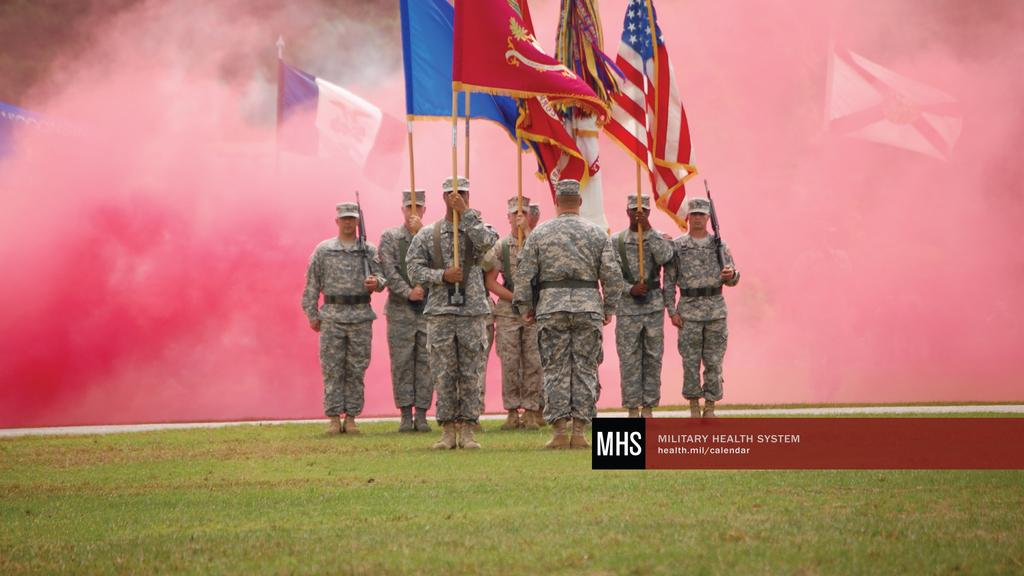What is the main subject of the image? The main subject of the image is a group of persons. What are the persons wearing in the image? The persons are wearing army dress in the image. What are the persons doing in the image? The persons are standing and holding flags in their hands. What can be seen in the background of the image? There is smoke in the background of the image. What type of experience can be gained from wearing a skirt in the image? There is no skirt present in the image, and therefore no such experience can be gained. 